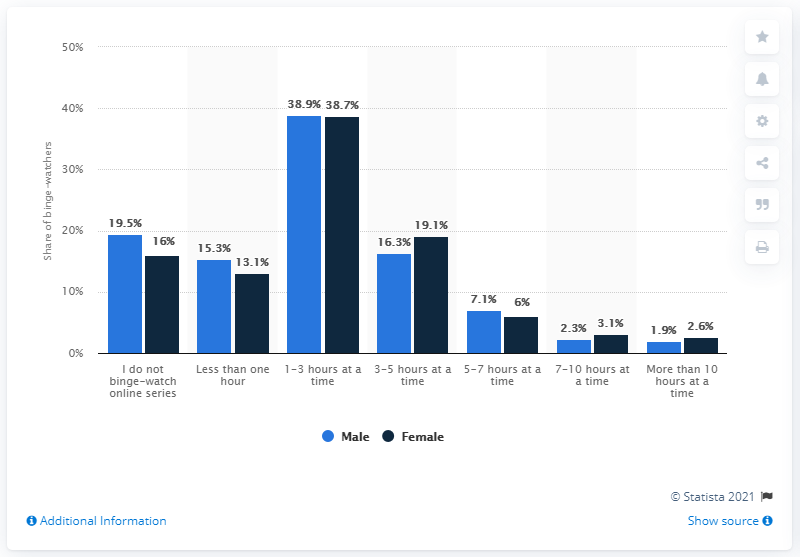Specify some key components in this picture. A recent survey found that 7.1% of men reported watching an online series for five to seven hours in one sitting. According to the data, 7.1% of men reported spending between five and seven hours watching an online series in one sitting. 